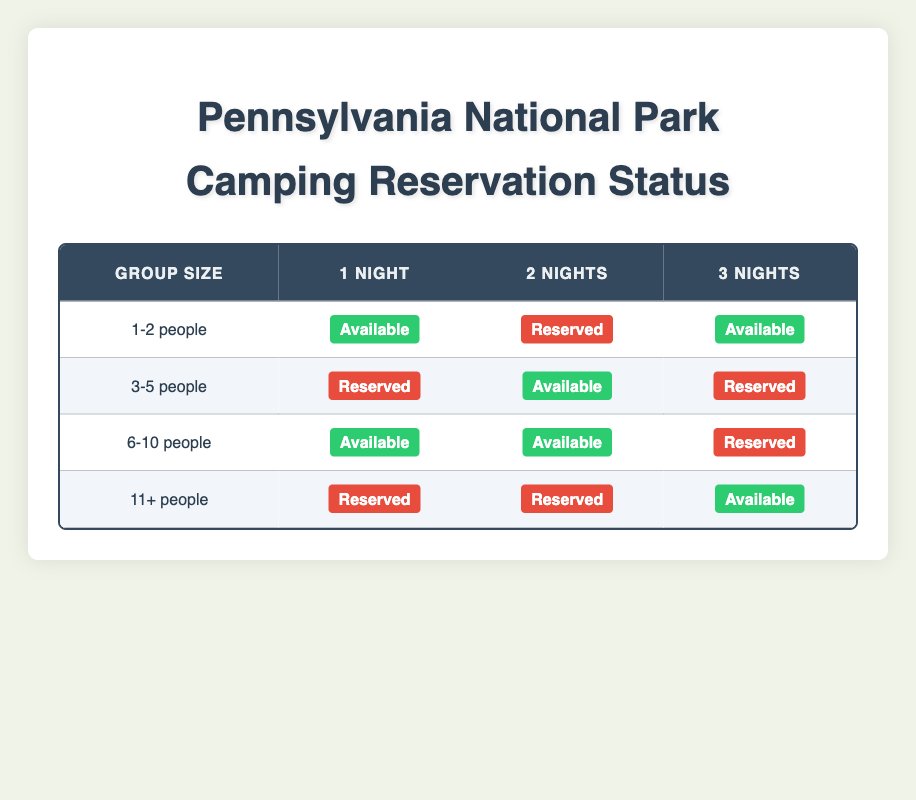What is the reservation status for 1-2 people staying for 1 night? According to the table, the status for 1-2 people staying for 1 night is "Available." This information can be found in the row corresponding to the group size of 1-2 people and the column for 1 Night.
Answer: Available How many total group sizes have an "Available" status for a 2-night stay? The table can be examined to find group sizes with "Available" status for 2 nights. The group sizes 1-2 people and 3-5 people both have an "Available" status, so there are a total of 2 group sizes fitting that criteria.
Answer: 2 Is there a group size of 6-10 people available for 3 nights? Looking at the table, the status for the group size of 6-10 people for 3 nights is "Reserved," which means they are not available. Thus the answer is no.
Answer: No Which group size has the highest number of nights available? To determine this, we need to evaluate each group size and their availability for each length of stay. The group size of 6-10 people has "Available" status for both 1 Night and 2 Nights, while the other group sizes have limited availability. Therefore, the maximum number of nights available for any group size is 2.
Answer: 2 For 11+ people, what are the available durations for reservations? In the table, for the group size of 11+ people, the only available duration is for 3 nights, as both 1 Night and 2 Nights show a "Reserved" status. So, the answer highlights that 3 nights is the only duration available.
Answer: 3 Nights How many total durations have a "Reserved" status for the group size of 3-5 people? Reviewing the table, the group size of 3-5 people has a "Reserved" status for 1 Night and for 3 Nights, totaling 2 durations that are reserved for that size group.
Answer: 2 Is it true that all group sizes with "Reserved" status for 1 night are for groups larger than 2 people? Looking at the table, the only group size with "Reserved" status for 1 night is 3-5 people and 11+ people. The group size of 1-2 people has an "Available" status. Therefore, the statement is true.
Answer: True What is the average availability status for 2 nights across all groups? To calculate this, we examine the 2-night availability. There are 3 groups: 1-2 people (Reserved), 3-5 people (Available), and 11+ people (Reserved) totaling 1 available and 2 reserved. So, the average can be calculated as (1 available)/(3 groups) = approximately 0.33 availability status, indicating around one-third are available.
Answer: Approximately 0.33 Availability 